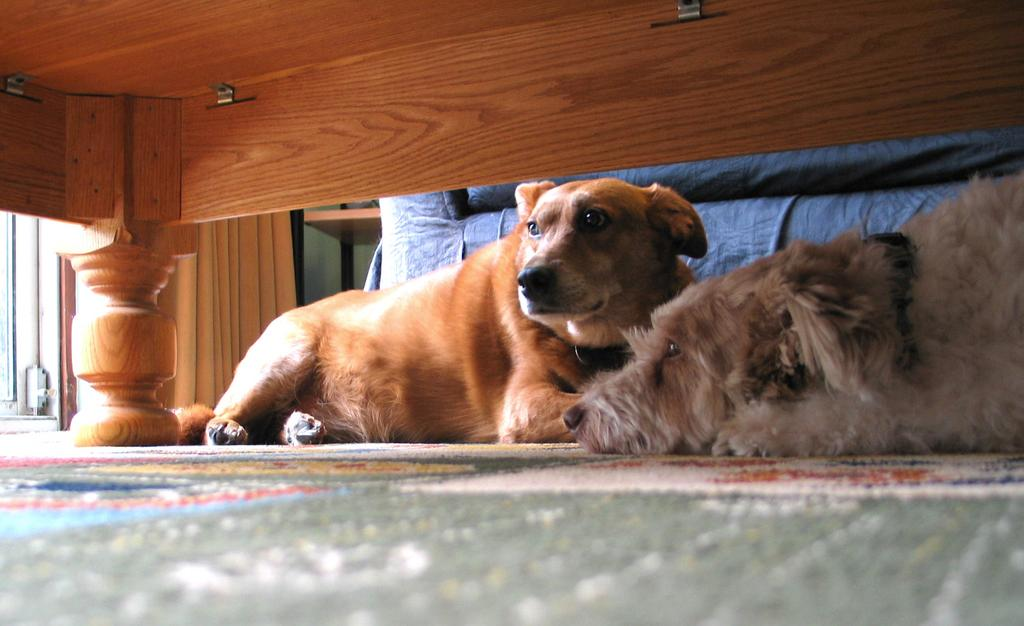How many dogs are present in the image? There are two dogs in the image. What surface are the dogs on? The dogs are on a carpet. What type of furniture can be seen in the image? There is a wooden bed in the image. What type of wool is being used to make the property in the image? There is no wool or property mentioned in the image; it features two dogs on a carpet and a wooden bed. 